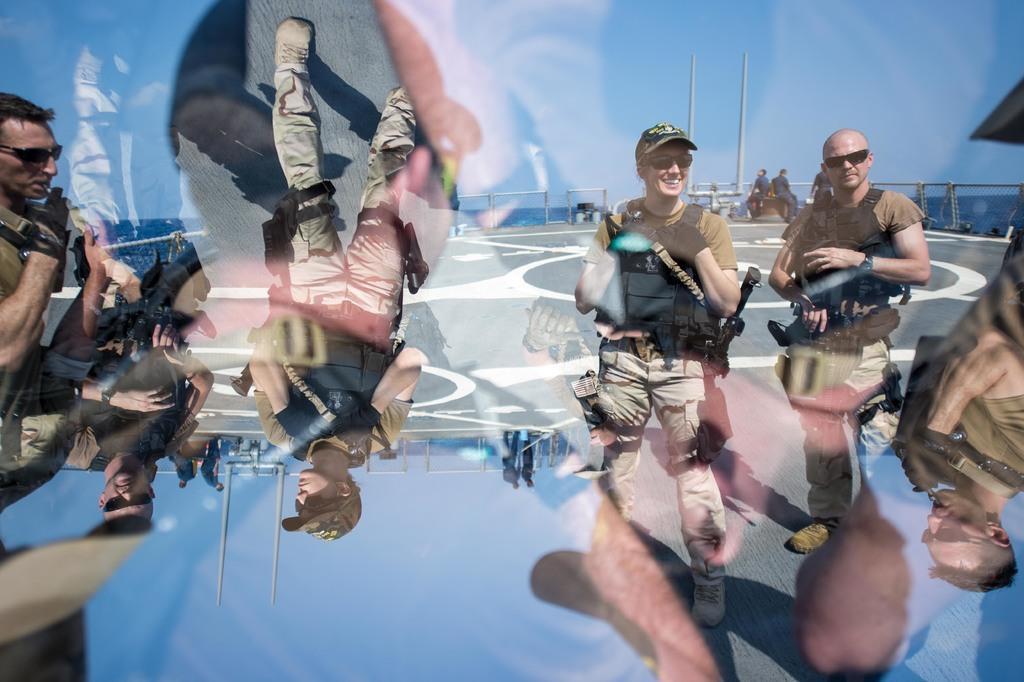Describe this image in one or two sentences. This image looks like an edited photo in which I can see a group of people on the road and are holding some objects in their hand. In the background I can see a fence, poles, mountains and the sky. 